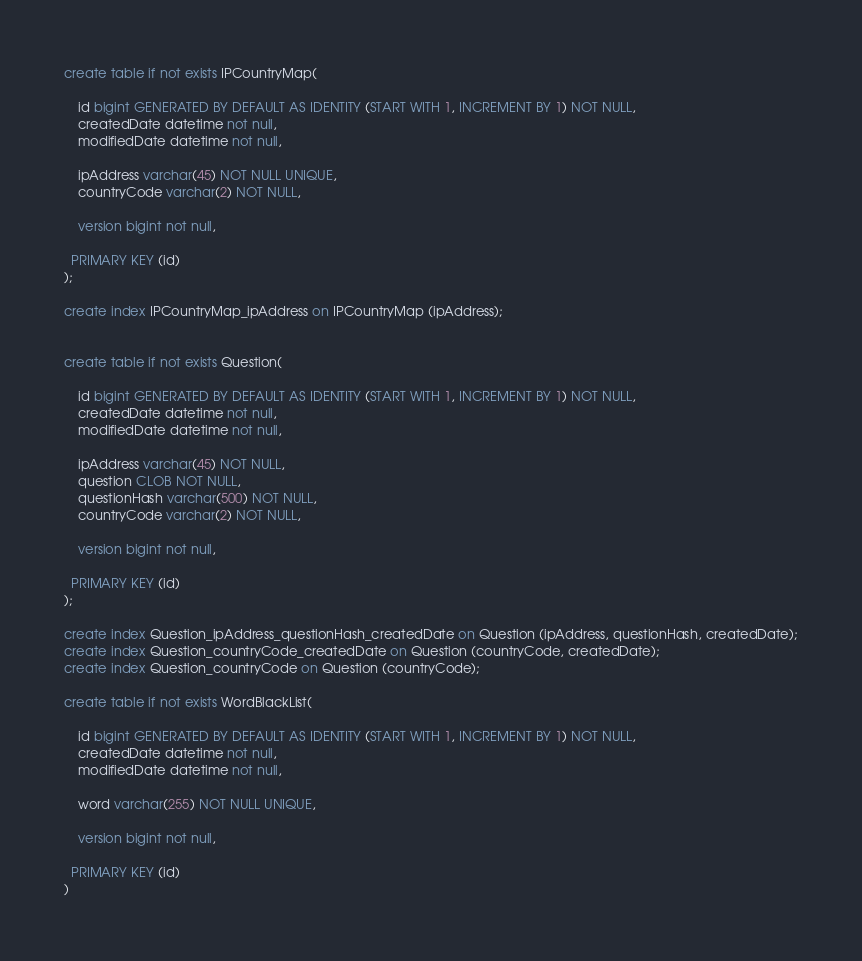<code> <loc_0><loc_0><loc_500><loc_500><_SQL_>create table if not exists IPCountryMap(

	id bigint GENERATED BY DEFAULT AS IDENTITY (START WITH 1, INCREMENT BY 1) NOT NULL,
	createdDate datetime not null,
	modifiedDate datetime not null,
	
	ipAddress varchar(45) NOT NULL UNIQUE,
	countryCode varchar(2) NOT NULL,
	
	version bigint not null,
	
  PRIMARY KEY (id)
);

create index IPCountryMap_ipAddress on IPCountryMap (ipAddress);


create table if not exists Question(

	id bigint GENERATED BY DEFAULT AS IDENTITY (START WITH 1, INCREMENT BY 1) NOT NULL,
	createdDate datetime not null,
	modifiedDate datetime not null,
	
	ipAddress varchar(45) NOT NULL,
	question CLOB NOT NULL,
	questionHash varchar(500) NOT NULL,
	countryCode varchar(2) NOT NULL,
	
	version bigint not null,
	
  PRIMARY KEY (id)
);

create index Question_ipAddress_questionHash_createdDate on Question (ipAddress, questionHash, createdDate);
create index Question_countryCode_createdDate on Question (countryCode, createdDate);
create index Question_countryCode on Question (countryCode);

create table if not exists WordBlackList(

	id bigint GENERATED BY DEFAULT AS IDENTITY (START WITH 1, INCREMENT BY 1) NOT NULL,
	createdDate datetime not null,
	modifiedDate datetime not null,
	
	word varchar(255) NOT NULL UNIQUE,
	
	version bigint not null,
	
  PRIMARY KEY (id)
)

</code> 